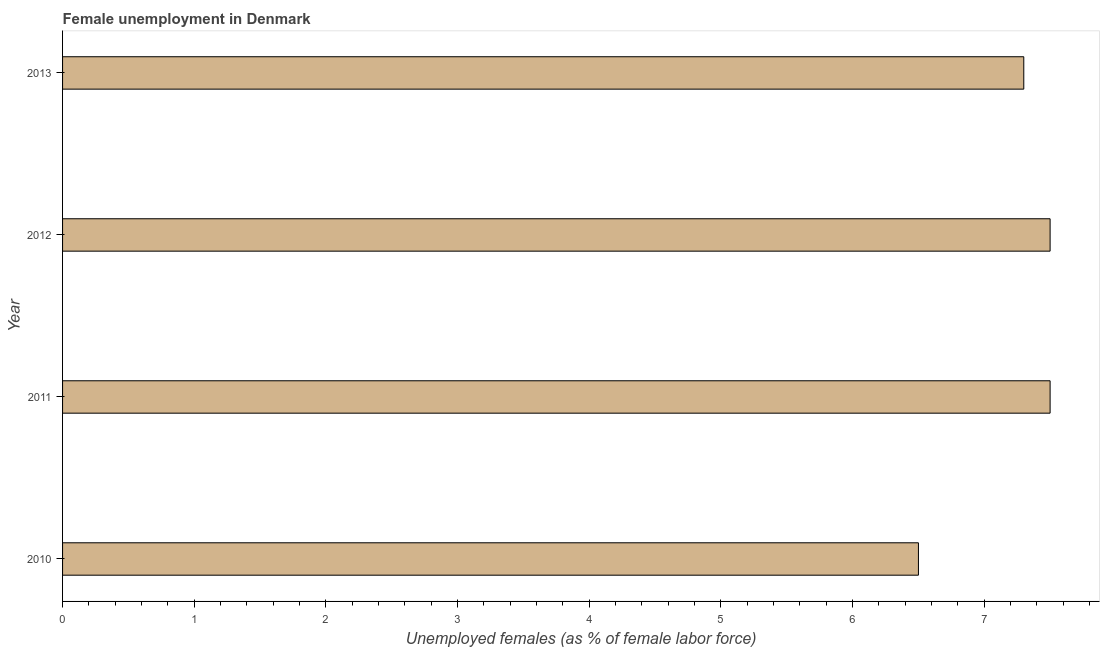What is the title of the graph?
Ensure brevity in your answer.  Female unemployment in Denmark. What is the label or title of the X-axis?
Your answer should be very brief. Unemployed females (as % of female labor force). What is the unemployed females population in 2011?
Offer a very short reply. 7.5. Across all years, what is the minimum unemployed females population?
Ensure brevity in your answer.  6.5. In which year was the unemployed females population maximum?
Your response must be concise. 2011. What is the sum of the unemployed females population?
Your response must be concise. 28.8. What is the difference between the unemployed females population in 2010 and 2011?
Provide a succinct answer. -1. What is the median unemployed females population?
Your answer should be compact. 7.4. In how many years, is the unemployed females population greater than 7.4 %?
Offer a terse response. 2. Do a majority of the years between 2011 and 2013 (inclusive) have unemployed females population greater than 1.2 %?
Provide a succinct answer. Yes. What is the ratio of the unemployed females population in 2011 to that in 2012?
Provide a succinct answer. 1. In how many years, is the unemployed females population greater than the average unemployed females population taken over all years?
Your answer should be compact. 3. Are all the bars in the graph horizontal?
Your answer should be very brief. Yes. How many years are there in the graph?
Keep it short and to the point. 4. What is the difference between two consecutive major ticks on the X-axis?
Ensure brevity in your answer.  1. What is the Unemployed females (as % of female labor force) of 2010?
Your answer should be very brief. 6.5. What is the Unemployed females (as % of female labor force) of 2011?
Provide a short and direct response. 7.5. What is the Unemployed females (as % of female labor force) of 2013?
Ensure brevity in your answer.  7.3. What is the difference between the Unemployed females (as % of female labor force) in 2010 and 2011?
Provide a succinct answer. -1. What is the difference between the Unemployed females (as % of female labor force) in 2010 and 2013?
Provide a succinct answer. -0.8. What is the difference between the Unemployed females (as % of female labor force) in 2011 and 2012?
Your answer should be compact. 0. What is the difference between the Unemployed females (as % of female labor force) in 2011 and 2013?
Give a very brief answer. 0.2. What is the difference between the Unemployed females (as % of female labor force) in 2012 and 2013?
Provide a short and direct response. 0.2. What is the ratio of the Unemployed females (as % of female labor force) in 2010 to that in 2011?
Give a very brief answer. 0.87. What is the ratio of the Unemployed females (as % of female labor force) in 2010 to that in 2012?
Your answer should be compact. 0.87. What is the ratio of the Unemployed females (as % of female labor force) in 2010 to that in 2013?
Provide a succinct answer. 0.89. What is the ratio of the Unemployed females (as % of female labor force) in 2011 to that in 2013?
Give a very brief answer. 1.03. What is the ratio of the Unemployed females (as % of female labor force) in 2012 to that in 2013?
Ensure brevity in your answer.  1.03. 